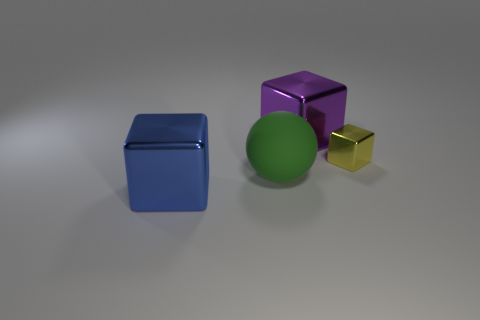What is the shape of the metal object that is on the left side of the large block that is behind the green object that is behind the blue shiny thing?
Keep it short and to the point. Cube. What is the green sphere on the left side of the yellow thing made of?
Give a very brief answer. Rubber. The other shiny block that is the same size as the blue shiny block is what color?
Offer a very short reply. Purple. What number of other objects are there of the same shape as the blue object?
Your answer should be very brief. 2. Does the blue shiny block have the same size as the purple shiny block?
Provide a succinct answer. Yes. Is the number of green things that are left of the blue block greater than the number of rubber spheres to the left of the matte object?
Offer a terse response. No. What number of other objects are the same size as the rubber ball?
Offer a terse response. 2. Do the shiny thing that is left of the purple metallic thing and the small thing have the same color?
Your answer should be compact. No. Is the number of objects that are right of the rubber ball greater than the number of large red matte cylinders?
Keep it short and to the point. Yes. Is there any other thing of the same color as the small metal block?
Your response must be concise. No. 